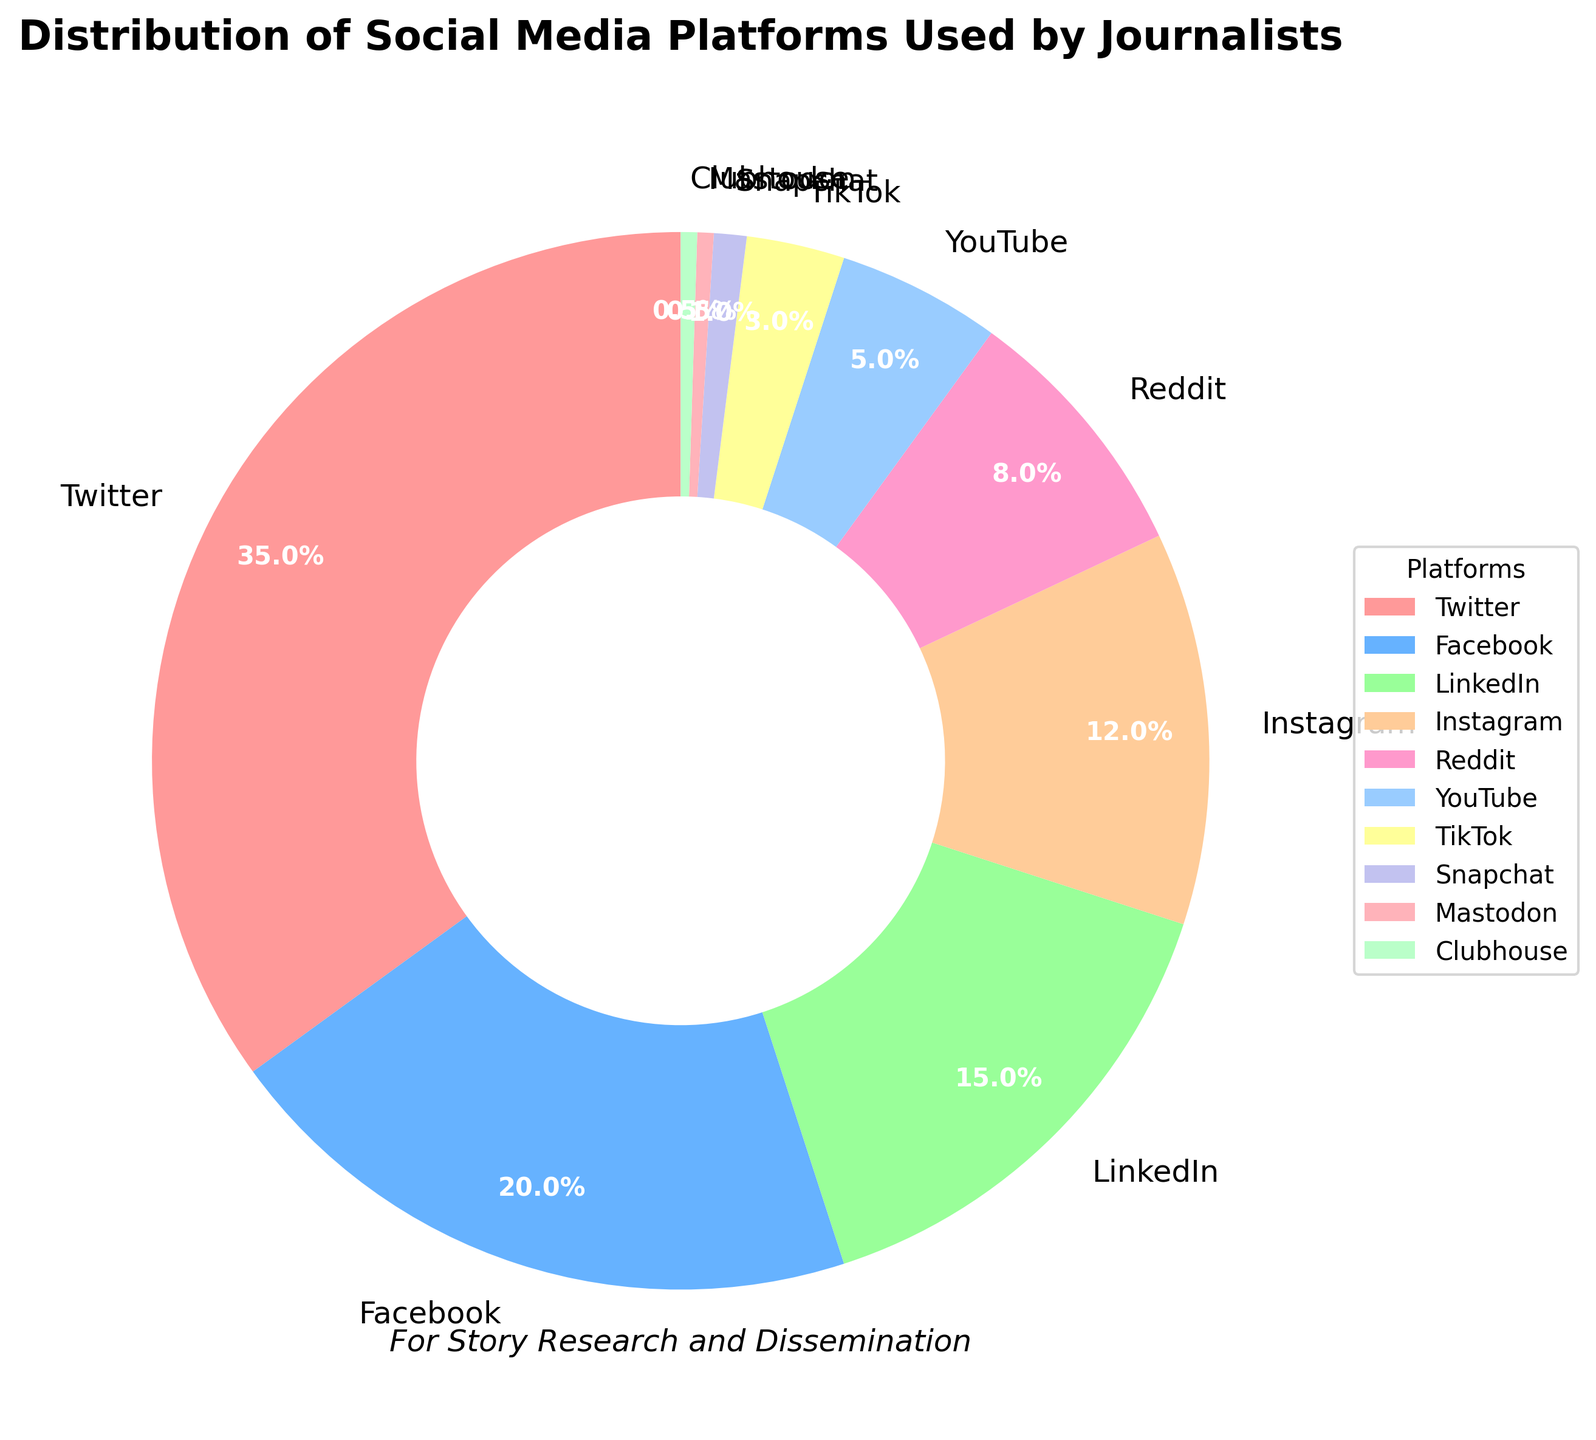What's the largest social media platform used by journalists for story research and dissemination? The pie chart shows different segments representing various social media platforms. By analyzing the largest slice in the chart, it is evident that Twitter is the largest, indicated by it having the highest percentage.
Answer: Twitter Which two platforms combined make up almost half of the usage by journalists? Analyzing the chart, Twitter has 35% and Facebook has 20%. When combined, their percentages total 55%, which is well over half.Thus shows that, Twitter and Facebook together form the largest combined share.
Answer: Twitter and Facebook What is the total percentage of social media platforms used by journalists that each has less than 5% usage? Adding the segments for platforms with under 5% usage: YouTube has 5%, TikTok has 3%, Snapchat has 1%, Mastodon has 0.5%, and Clubhouse has 0.5%. Summing these, we get 5 + 3 + 1 + 0.5 + 0.5 = 10% of total usage
Answer: 10% How does LinkedIn's usage compare to Reddit's usage? The pie chart segment for LinkedIn shows 15%, while Reddit's segment shows 8%. Therefore, LinkedIn’s usage is nearly twice that of Reddit's usage.
Answer: LinkedIn has nearly double the usage of Reddit What is the combined share of Instagram and LinkedIn? By summing up the percentages of Instagram (12%) and LinkedIn (15%), we get 12 + 15 = 27%.
Answer: 27% Which social media platform has the least usage by journalists? By examining the smallest segment in the pie chart, it is evident that both Mastodon and Clubhouse have the smallest usage with each having 0.5%.
Answer: Mastodon and Clubhouse Are there more journalists using Instagram or YouTube, and by how much? The pie chart shows Instagram at 12% and YouTube at 5%. The difference is calculated by subtracting YouTube’s percentage from Instagram’s: 12 - 5 = 7%.
Answer: 7% more journalists use Instagram than YouTube What is the median usage percentage of the social media platforms? To find the median, we list the percentages in ascending order: 0.5, 0.5, 1, 3, 5, 8, 12, 15, 20, 35. The median is the average of the 5th and 6th values (5 and 8): (5 + 8) / 2 = 6.5%.
Answer: 6.5% How does the combined usage of the three least used platforms compare to LinkedIn’s usage? The least used platforms (Mastodon, Clubhouse, and Snapchat) have combined usage of 0.5 + 0.5 + 1 = 2%. LinkedIn alone has 15%. Therefore, LinkedIn’s usage is significantly higher.
Answer: LinkedIn's usage is significantly higher than the combined usage of the three least used platforms How does Facebook’s usage compare with the combined usage of Reddit and Instagram? Facebook’s usage is 20%, and the sum of Reddit (8%) and Instagram (12%) is 8 + 12 = 20%. Therefore, Facebook’s usage is equal to the combined usage of Reddit and Instagram.
Answer: Equal usage 